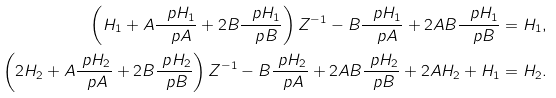Convert formula to latex. <formula><loc_0><loc_0><loc_500><loc_500>\left ( H _ { 1 } + A \frac { \ p H _ { 1 } } { \ p A } + 2 B \frac { \ p H _ { 1 } } { \ p B } \right ) Z ^ { - 1 } - B \frac { \ p H _ { 1 } } { \ p A } + 2 A B \frac { \ p H _ { 1 } } { \ p B } & = H _ { 1 } , \\ \left ( 2 H _ { 2 } + A \frac { \ p H _ { 2 } } { \ p A } + 2 B \frac { \ p H _ { 2 } } { \ p B } \right ) Z ^ { - 1 } - B \frac { \ p H _ { 2 } } { \ p A } + 2 A B \frac { \ p H _ { 2 } } { \ p B } + 2 A H _ { 2 } + H _ { 1 } & = H _ { 2 } .</formula> 